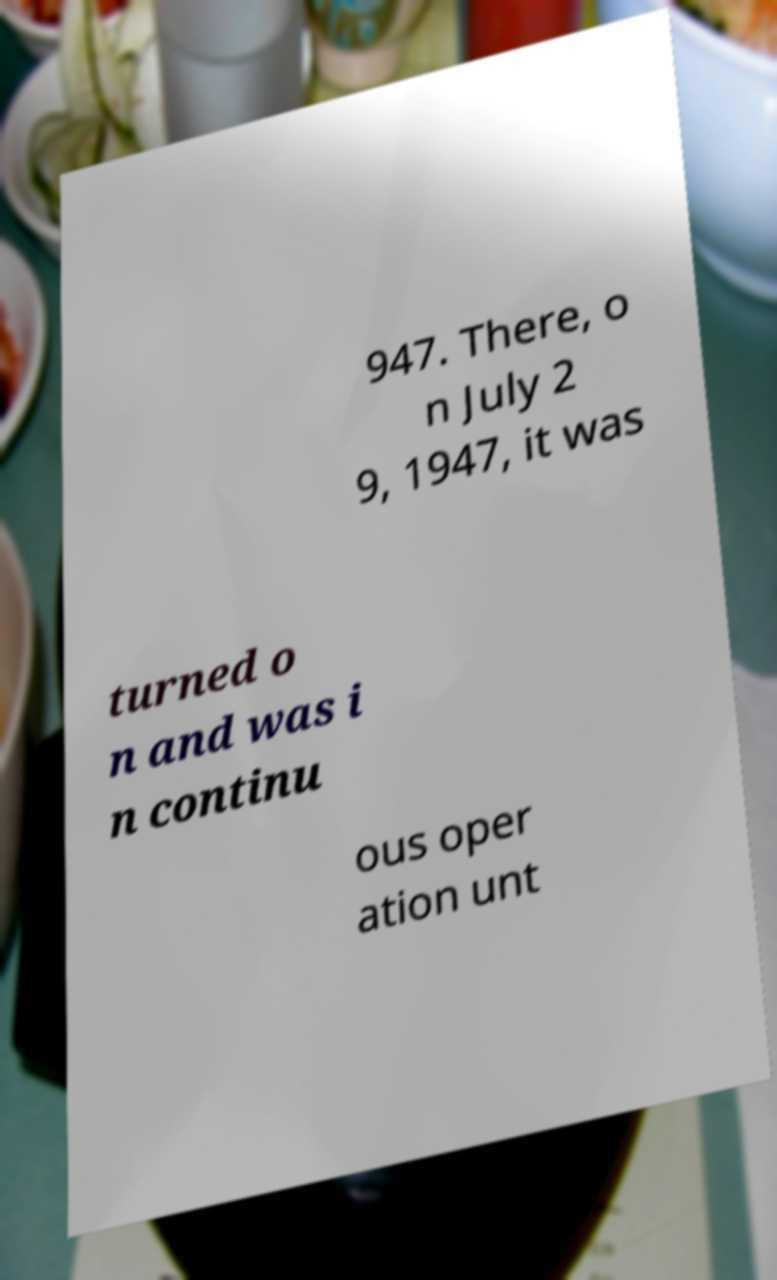What messages or text are displayed in this image? I need them in a readable, typed format. 947. There, o n July 2 9, 1947, it was turned o n and was i n continu ous oper ation unt 